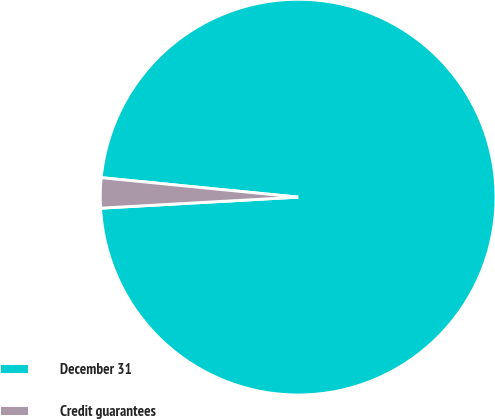<chart> <loc_0><loc_0><loc_500><loc_500><pie_chart><fcel>December 31<fcel>Credit guarantees<nl><fcel>97.54%<fcel>2.46%<nl></chart> 